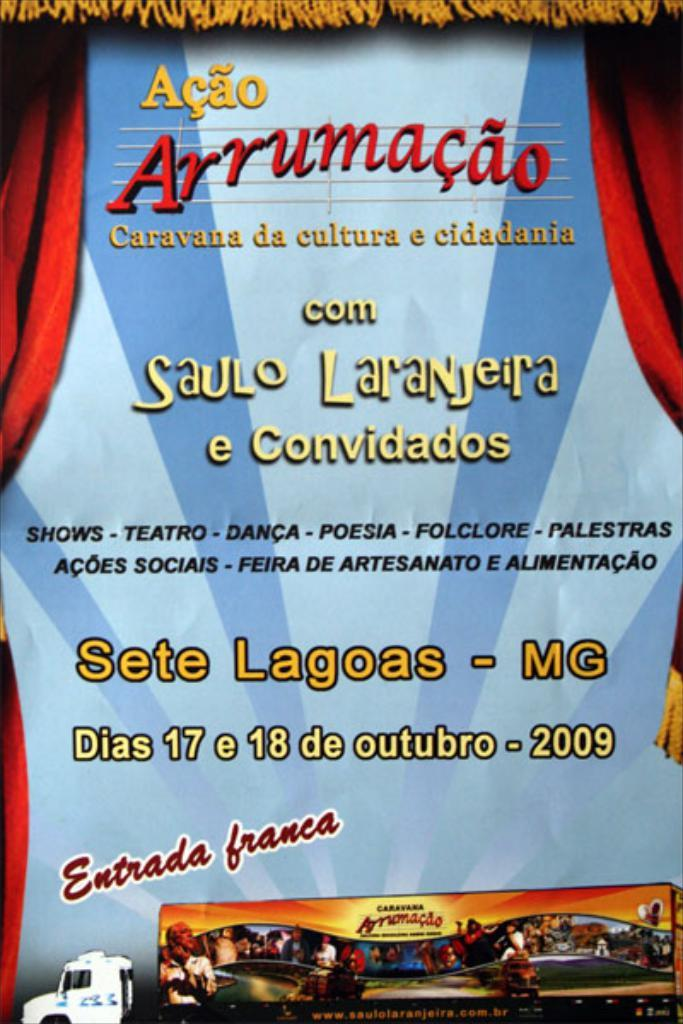<image>
Render a clear and concise summary of the photo. A theatre drawing with Acao Arrumacao as the title. 